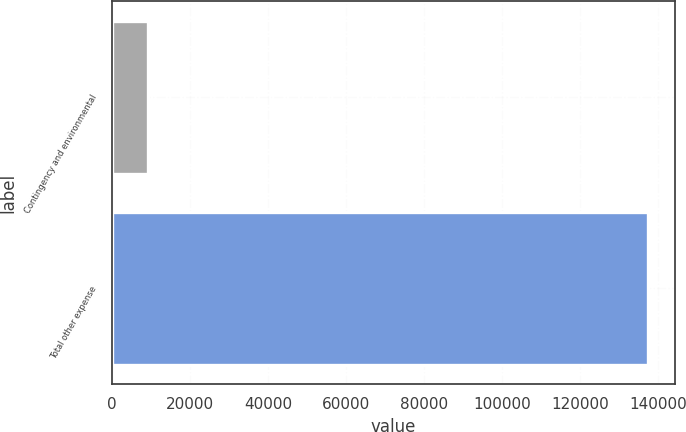Convert chart to OTSL. <chart><loc_0><loc_0><loc_500><loc_500><bar_chart><fcel>Contingency and environmental<fcel>Total other expense<nl><fcel>9277<fcel>137386<nl></chart> 